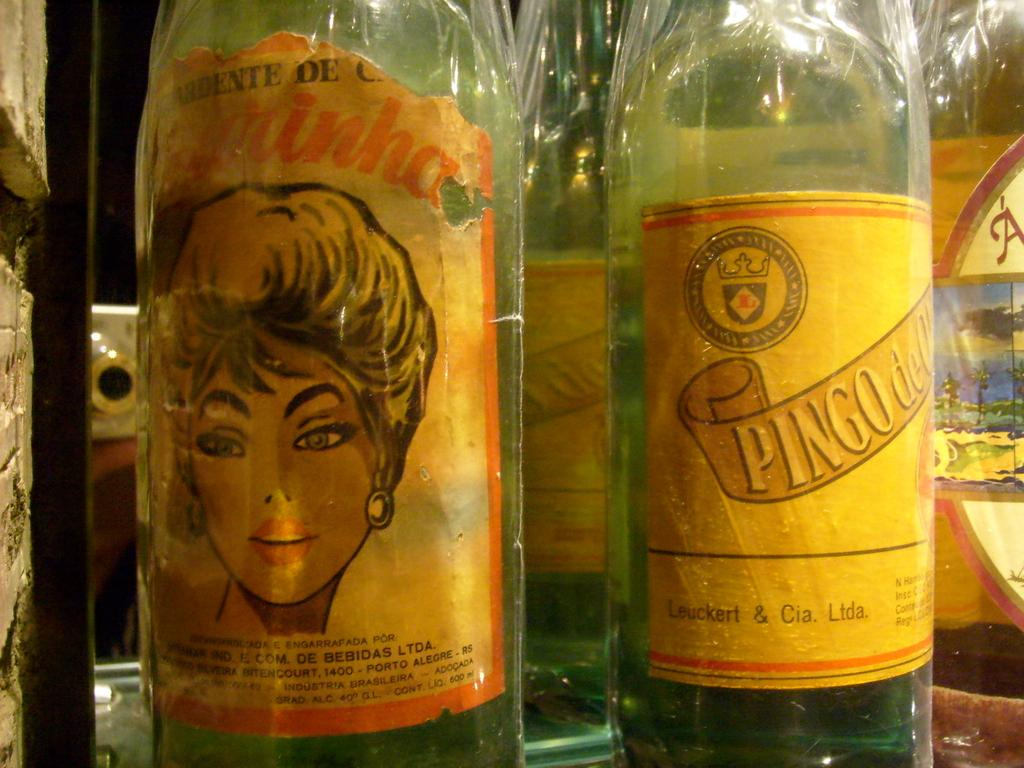What objects are on the table in the image? There are bottles on a table in the image. What else can be seen in the image besides the table and bottles? There is a wall visible in the image. What degree does the judge have in the image? There is no judge present in the image, so it is not possible to determine their degree. 